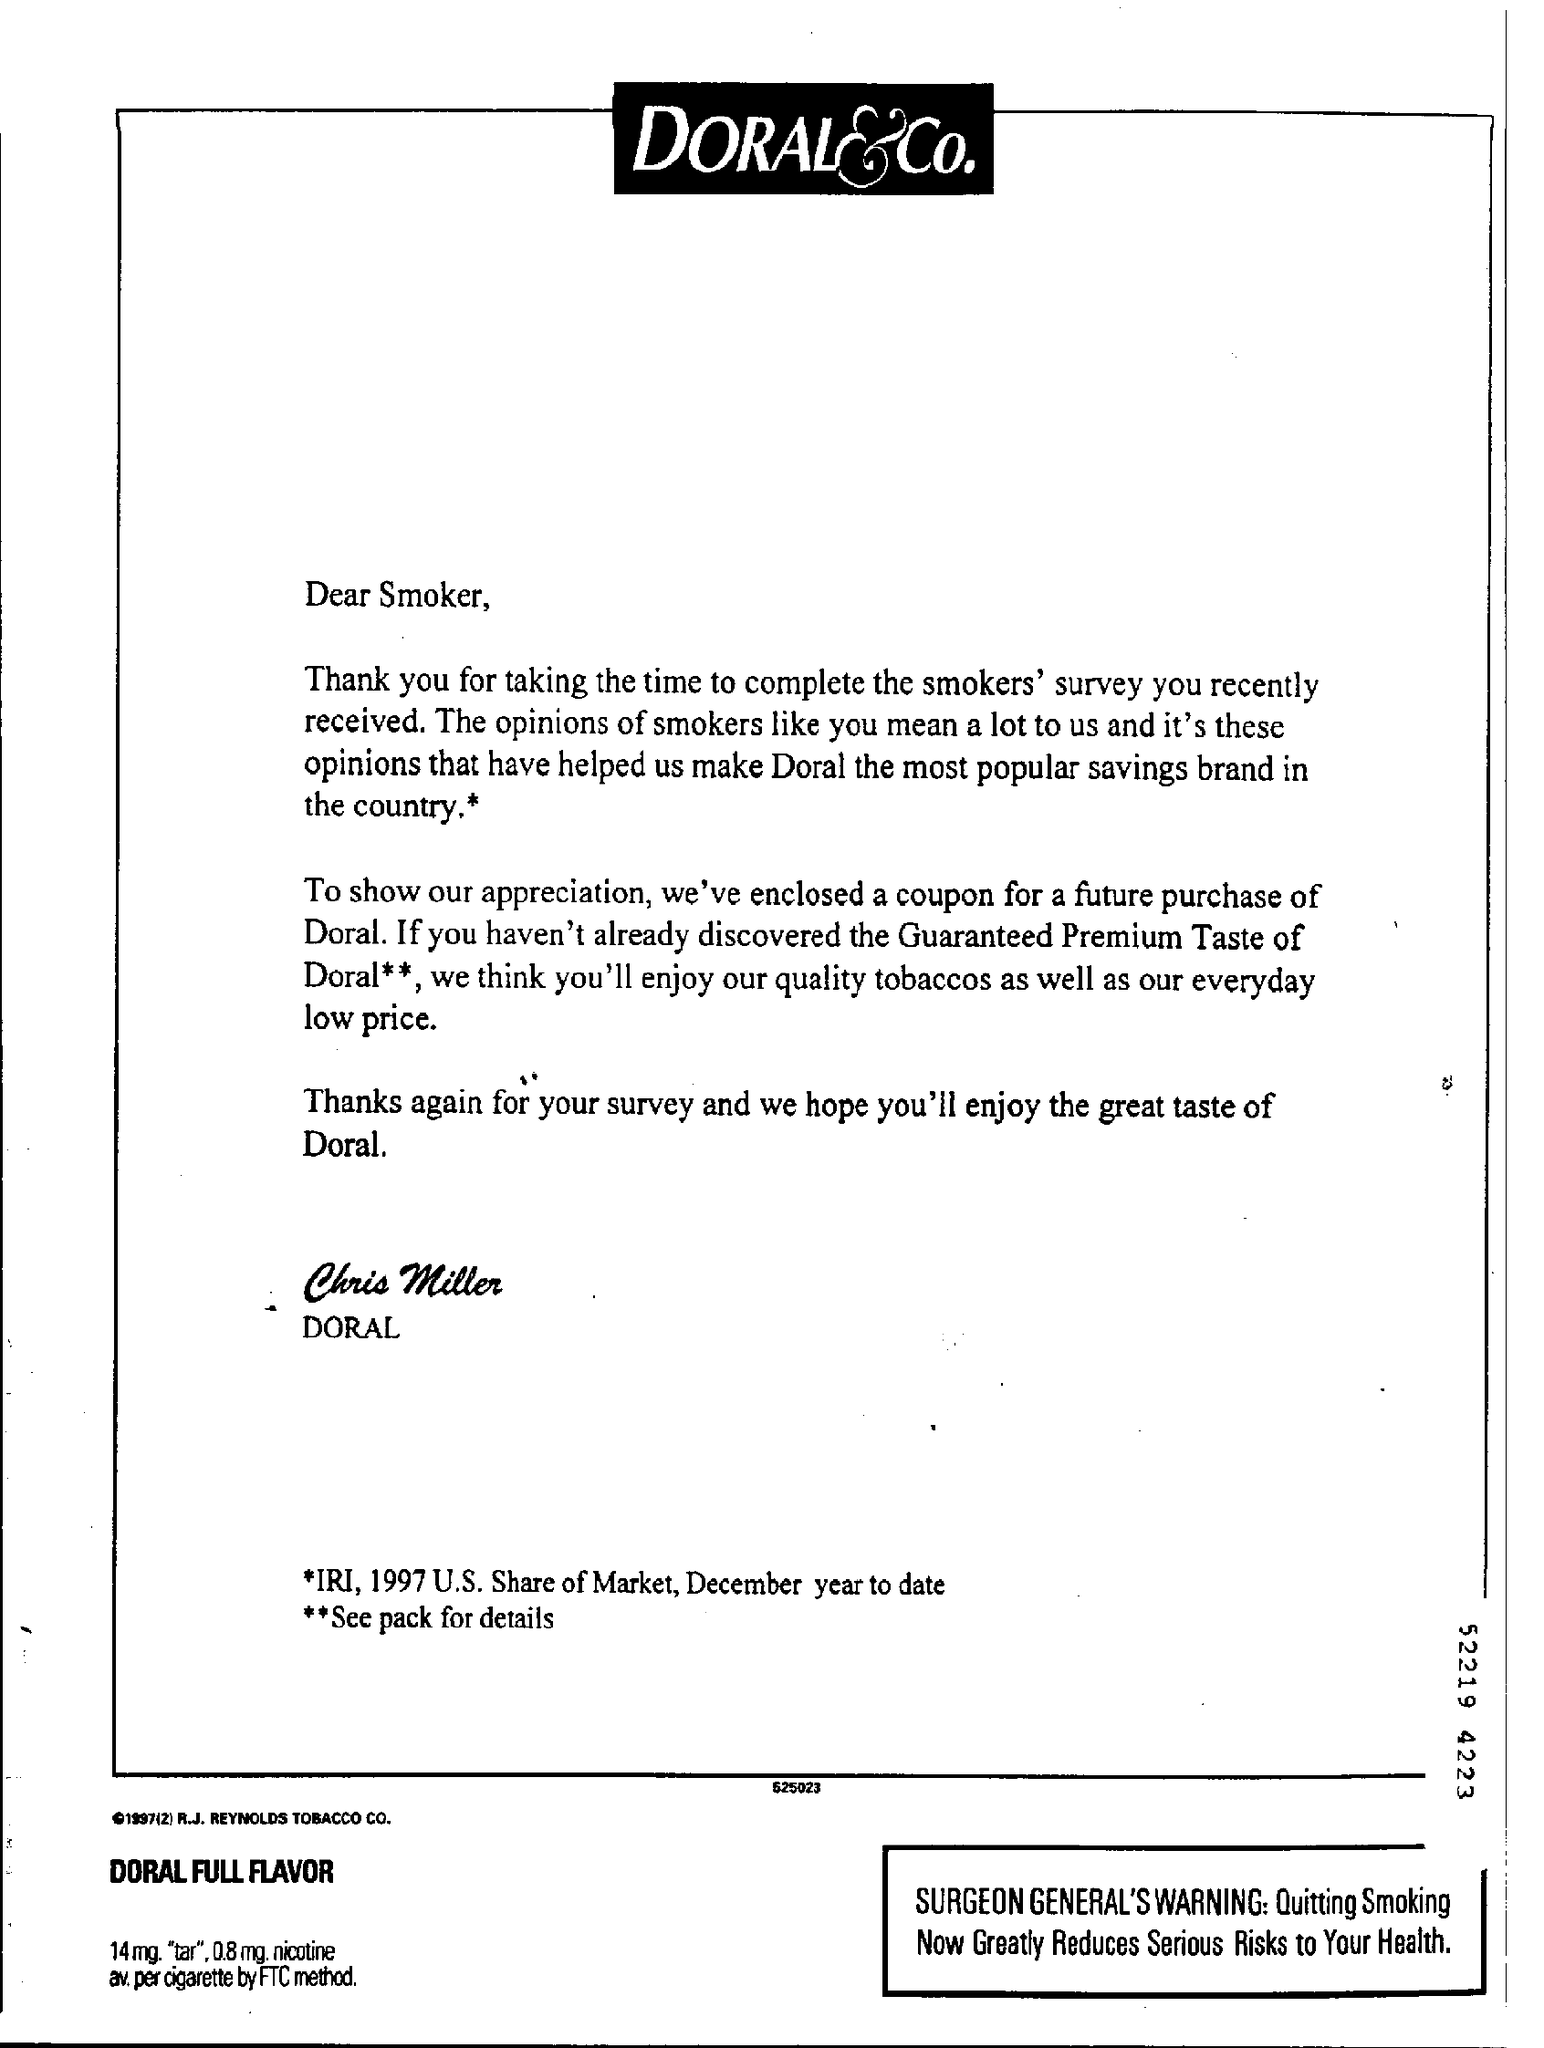Mention a couple of crucial points in this snapshot. The author of this letter is Chris Miller. 